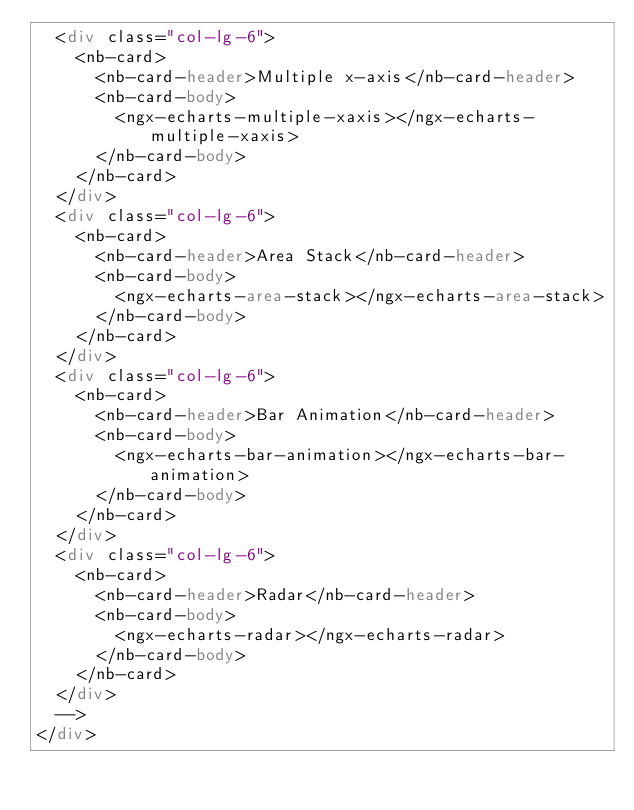<code> <loc_0><loc_0><loc_500><loc_500><_HTML_>  <div class="col-lg-6">
    <nb-card>
      <nb-card-header>Multiple x-axis</nb-card-header>
      <nb-card-body>
        <ngx-echarts-multiple-xaxis></ngx-echarts-multiple-xaxis>
      </nb-card-body>
    </nb-card>
  </div>
  <div class="col-lg-6">
    <nb-card>
      <nb-card-header>Area Stack</nb-card-header>
      <nb-card-body>
        <ngx-echarts-area-stack></ngx-echarts-area-stack>
      </nb-card-body>
    </nb-card>
  </div>
  <div class="col-lg-6">
    <nb-card>
      <nb-card-header>Bar Animation</nb-card-header>
      <nb-card-body>
        <ngx-echarts-bar-animation></ngx-echarts-bar-animation>
      </nb-card-body>
    </nb-card>
  </div>
  <div class="col-lg-6">
    <nb-card>
      <nb-card-header>Radar</nb-card-header>
      <nb-card-body>
        <ngx-echarts-radar></ngx-echarts-radar>
      </nb-card-body>
    </nb-card>
  </div>
  -->
</div>
</code> 